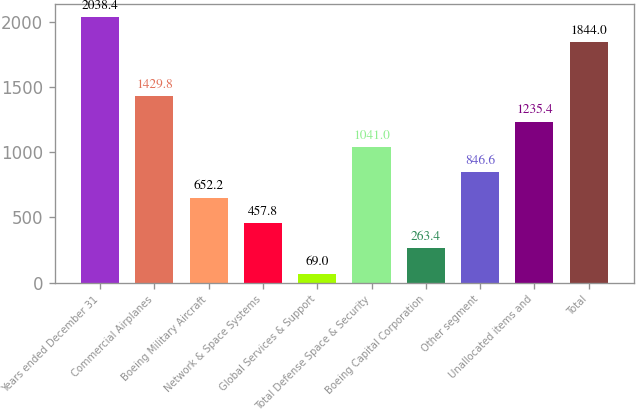Convert chart. <chart><loc_0><loc_0><loc_500><loc_500><bar_chart><fcel>Years ended December 31<fcel>Commercial Airplanes<fcel>Boeing Military Aircraft<fcel>Network & Space Systems<fcel>Global Services & Support<fcel>Total Defense Space & Security<fcel>Boeing Capital Corporation<fcel>Other segment<fcel>Unallocated items and<fcel>Total<nl><fcel>2038.4<fcel>1429.8<fcel>652.2<fcel>457.8<fcel>69<fcel>1041<fcel>263.4<fcel>846.6<fcel>1235.4<fcel>1844<nl></chart> 